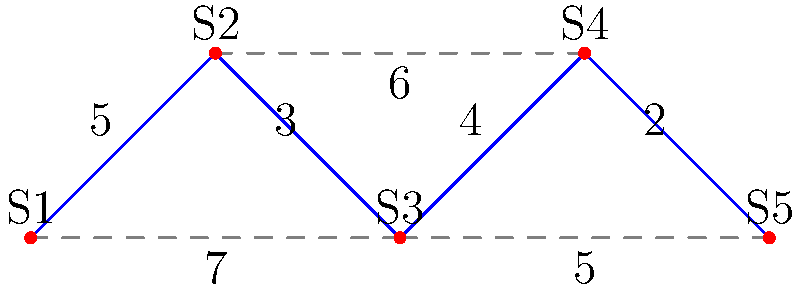As the superintendent of a school district in Illinois, you're tasked with optimizing the resource-sharing network between five schools (S1, S2, S3, S4, and S5). The diagram shows the possible connections between schools, with the associated costs (in thousands of dollars) for establishing each connection. What is the minimum total cost to connect all schools in a way that allows resources to be shared between any two schools, either directly or indirectly? To solve this problem, we need to find the minimum spanning tree (MST) of the given graph. The MST will connect all schools with the minimum total cost while ensuring that resources can be shared between any two schools. We can use Kruskal's algorithm to find the MST:

1. Sort all edges by weight (cost) in ascending order:
   (S3, S4): 2
   (S1, S2): 3
   (S2, S3): 3
   (S3, S5): 4
   (S1, S3): 7
   (S2, S4): 6
   (S4, S5): 5

2. Start with an empty set of edges and add edges in order, skipping those that would create a cycle:
   - Add (S3, S4): 2
   - Add (S1, S2): 3
   - Add (S2, S3): 3
   - Add (S3, S5): 4

3. After adding these four edges, all five schools are connected, and we have our MST.

4. Calculate the total cost by summing the weights of the selected edges:
   Total cost = 2 + 3 + 3 + 4 = 12

Therefore, the minimum total cost to connect all schools for efficient resource sharing is $12,000.
Answer: $12,000 